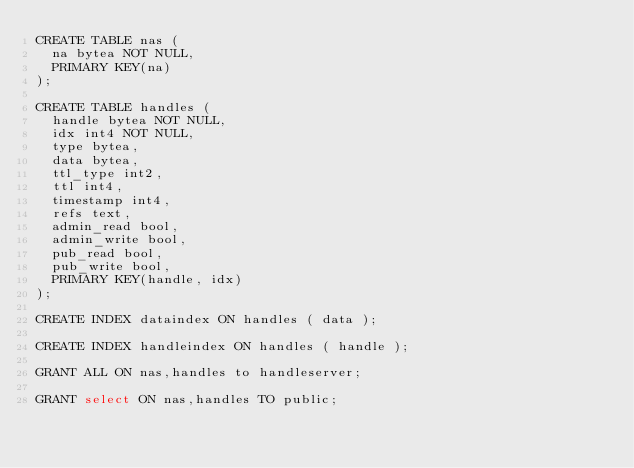Convert code to text. <code><loc_0><loc_0><loc_500><loc_500><_SQL_>CREATE TABLE nas (
  na bytea NOT NULL,
  PRIMARY KEY(na)
);

CREATE TABLE handles (
  handle bytea NOT NULL,
  idx int4 NOT NULL,
  type bytea,
  data bytea,
  ttl_type int2,
  ttl int4,
  timestamp int4,
  refs text,
  admin_read bool,
  admin_write bool,
  pub_read bool,
  pub_write bool,
  PRIMARY KEY(handle, idx)
);

CREATE INDEX dataindex ON handles ( data );

CREATE INDEX handleindex ON handles ( handle );

GRANT ALL ON nas,handles to handleserver;

GRANT select ON nas,handles TO public;
</code> 